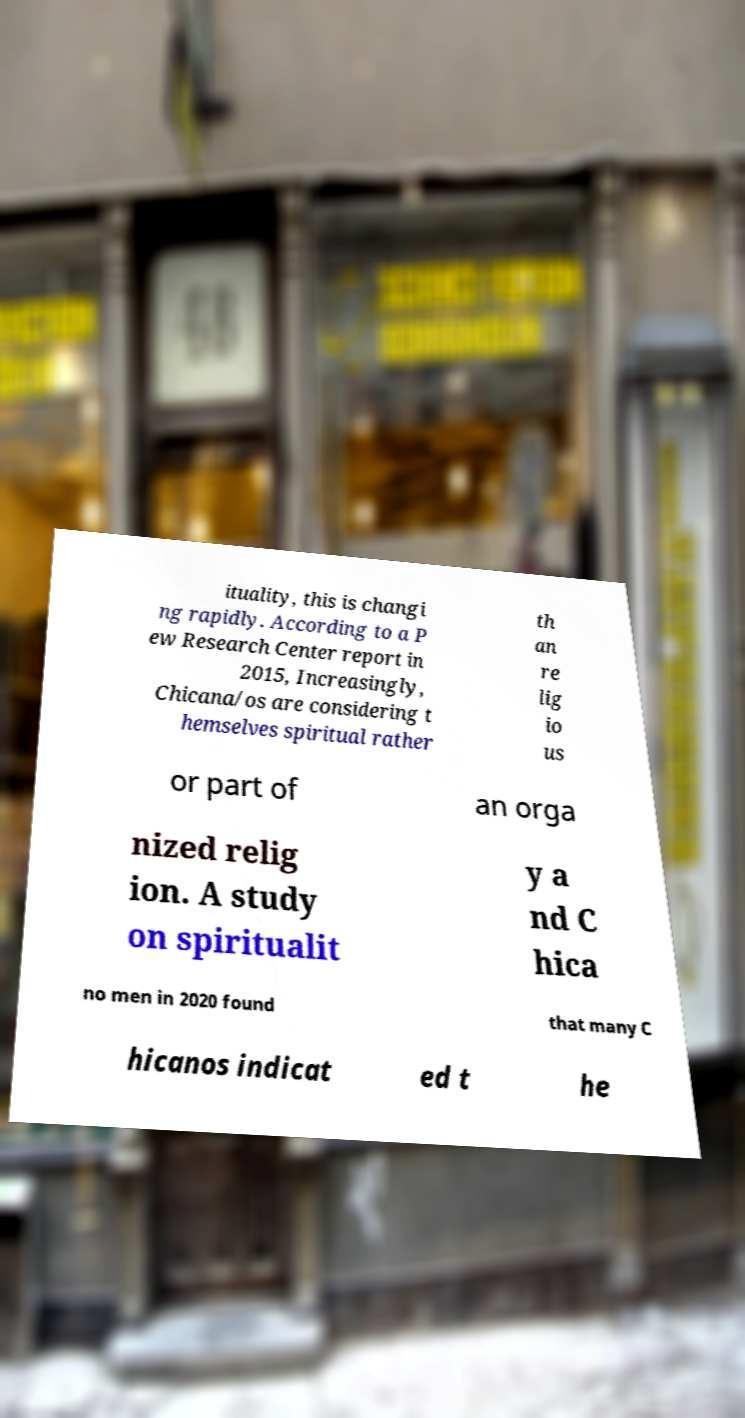Could you assist in decoding the text presented in this image and type it out clearly? ituality, this is changi ng rapidly. According to a P ew Research Center report in 2015, Increasingly, Chicana/os are considering t hemselves spiritual rather th an re lig io us or part of an orga nized relig ion. A study on spiritualit y a nd C hica no men in 2020 found that many C hicanos indicat ed t he 